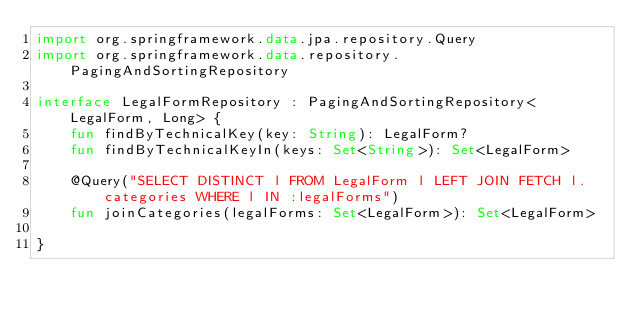Convert code to text. <code><loc_0><loc_0><loc_500><loc_500><_Kotlin_>import org.springframework.data.jpa.repository.Query
import org.springframework.data.repository.PagingAndSortingRepository

interface LegalFormRepository : PagingAndSortingRepository<LegalForm, Long> {
    fun findByTechnicalKey(key: String): LegalForm?
    fun findByTechnicalKeyIn(keys: Set<String>): Set<LegalForm>

    @Query("SELECT DISTINCT l FROM LegalForm l LEFT JOIN FETCH l.categories WHERE l IN :legalForms")
    fun joinCategories(legalForms: Set<LegalForm>): Set<LegalForm>

}</code> 